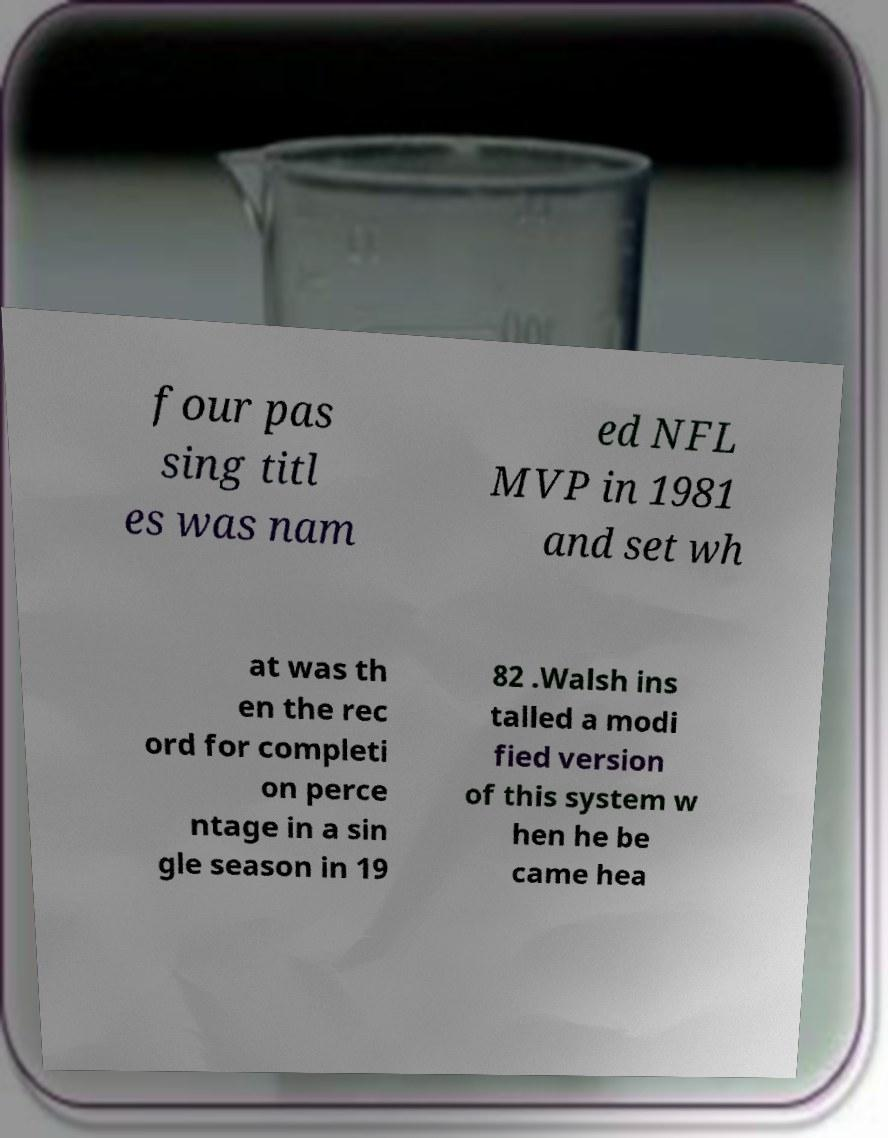For documentation purposes, I need the text within this image transcribed. Could you provide that? four pas sing titl es was nam ed NFL MVP in 1981 and set wh at was th en the rec ord for completi on perce ntage in a sin gle season in 19 82 .Walsh ins talled a modi fied version of this system w hen he be came hea 